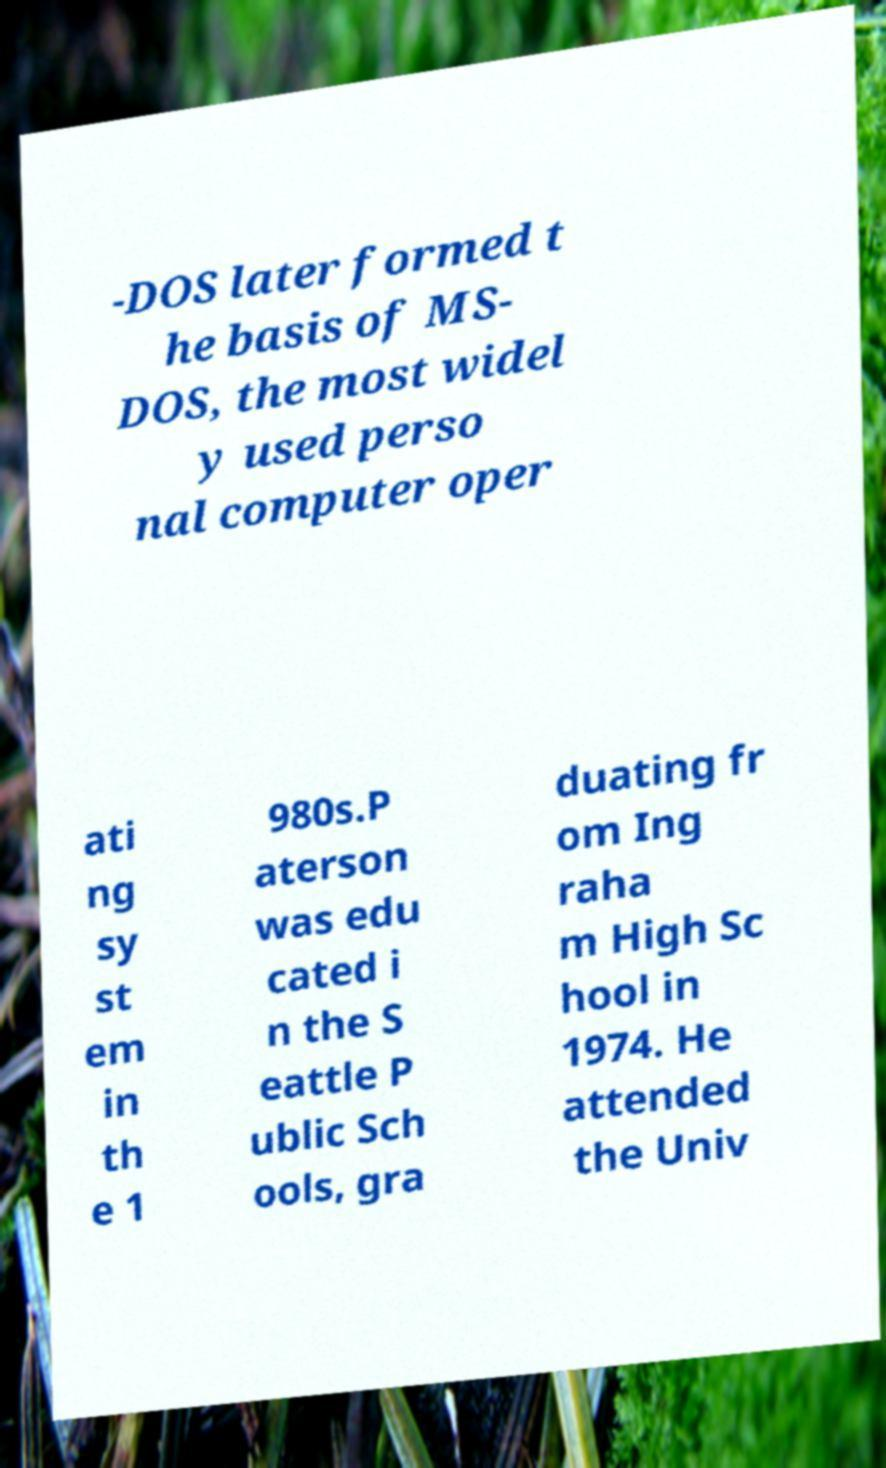Please read and relay the text visible in this image. What does it say? -DOS later formed t he basis of MS- DOS, the most widel y used perso nal computer oper ati ng sy st em in th e 1 980s.P aterson was edu cated i n the S eattle P ublic Sch ools, gra duating fr om Ing raha m High Sc hool in 1974. He attended the Univ 